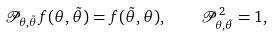<formula> <loc_0><loc_0><loc_500><loc_500>\mathcal { P } _ { \theta , \tilde { \theta } } f ( \theta , \tilde { \theta } ) = f ( \tilde { \theta } , \theta ) , \quad \mathcal { P } _ { \theta , \tilde { \theta } } ^ { 2 } = 1 ,</formula> 